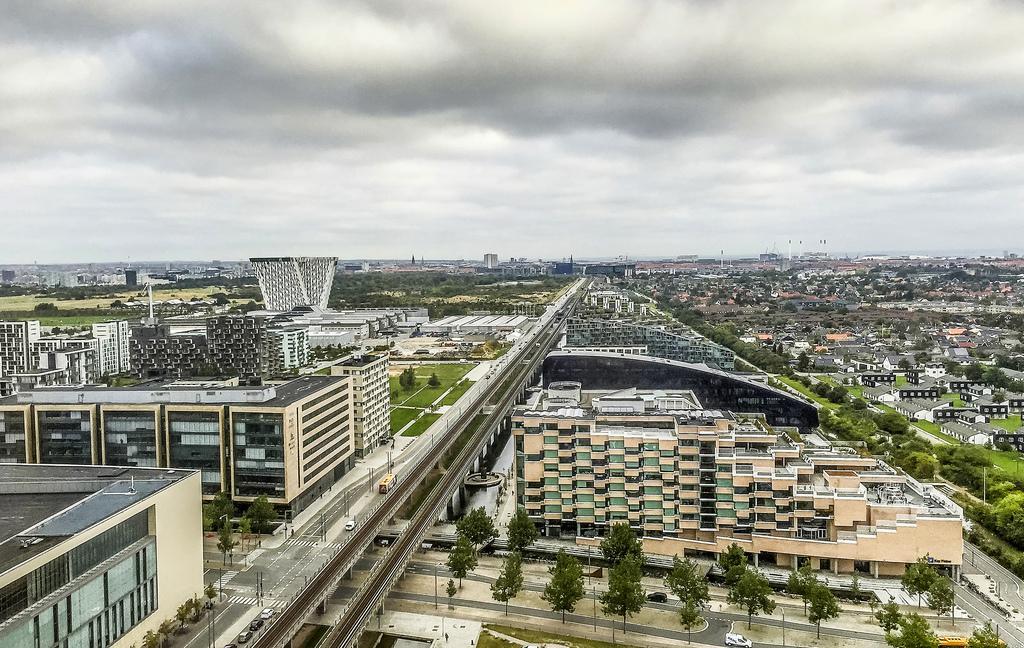Can you describe this image briefly? At the bottom of the image there are many buildings, trees, plants, roads, flyovers and many poles. At the top of the image there is a sky with clouds. 